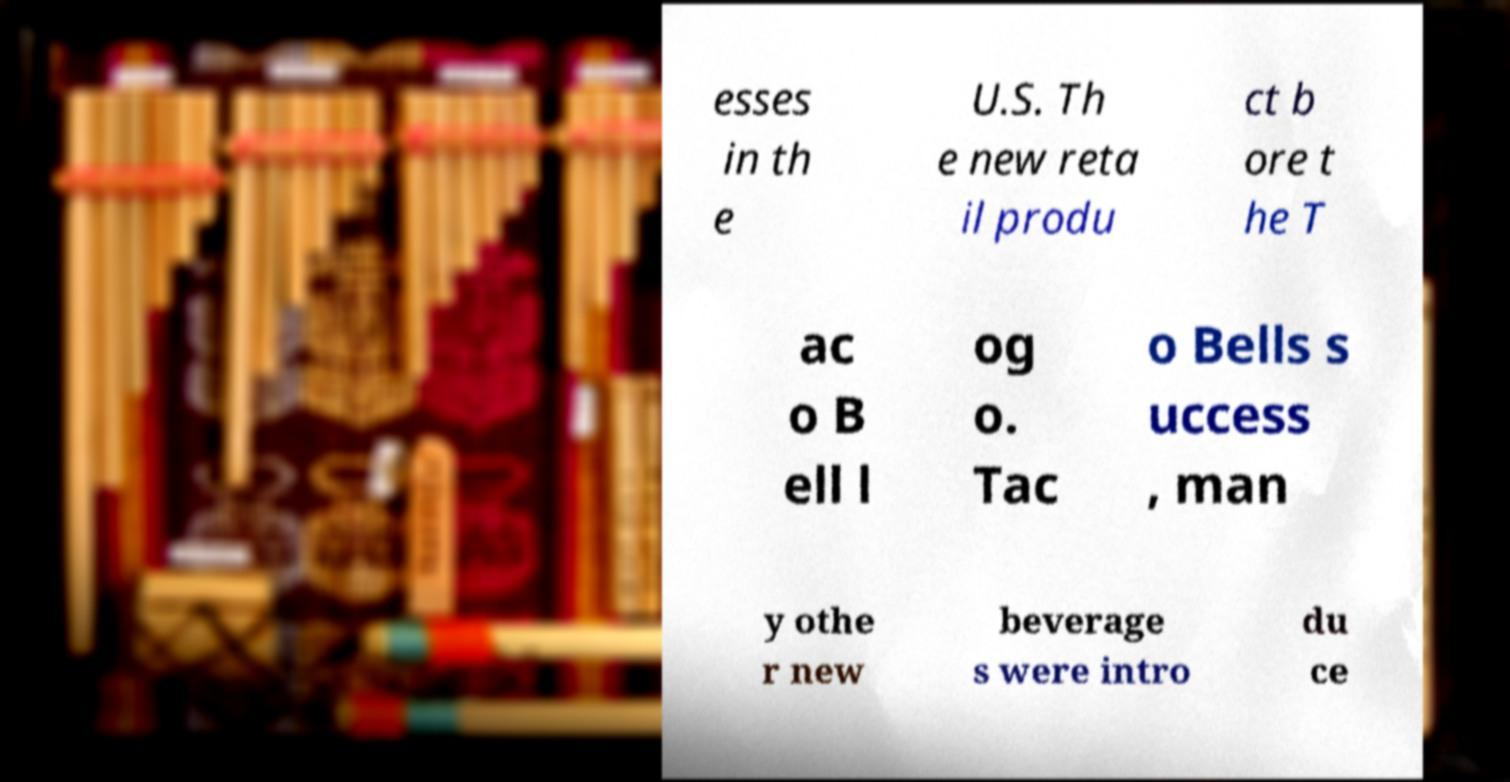Can you read and provide the text displayed in the image?This photo seems to have some interesting text. Can you extract and type it out for me? esses in th e U.S. Th e new reta il produ ct b ore t he T ac o B ell l og o. Tac o Bells s uccess , man y othe r new beverage s were intro du ce 